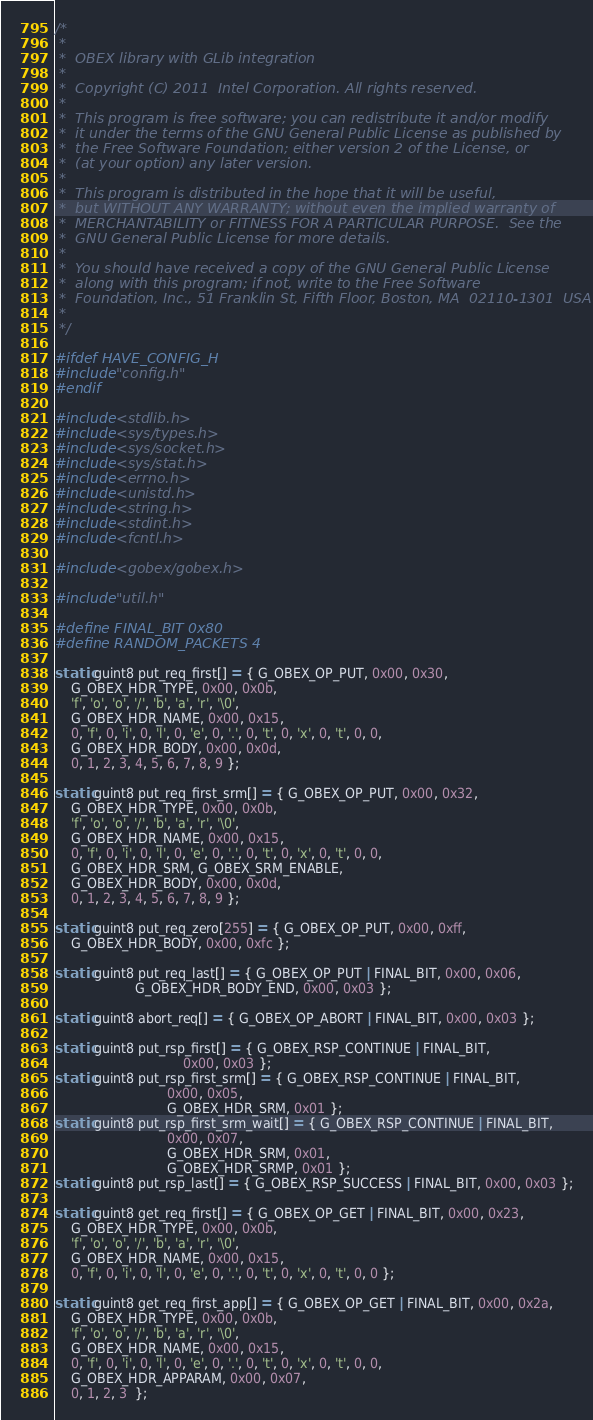Convert code to text. <code><loc_0><loc_0><loc_500><loc_500><_C_>/*
 *
 *  OBEX library with GLib integration
 *
 *  Copyright (C) 2011  Intel Corporation. All rights reserved.
 *
 *  This program is free software; you can redistribute it and/or modify
 *  it under the terms of the GNU General Public License as published by
 *  the Free Software Foundation; either version 2 of the License, or
 *  (at your option) any later version.
 *
 *  This program is distributed in the hope that it will be useful,
 *  but WITHOUT ANY WARRANTY; without even the implied warranty of
 *  MERCHANTABILITY or FITNESS FOR A PARTICULAR PURPOSE.  See the
 *  GNU General Public License for more details.
 *
 *  You should have received a copy of the GNU General Public License
 *  along with this program; if not, write to the Free Software
 *  Foundation, Inc., 51 Franklin St, Fifth Floor, Boston, MA  02110-1301  USA
 *
 */

#ifdef HAVE_CONFIG_H
#include "config.h"
#endif

#include <stdlib.h>
#include <sys/types.h>
#include <sys/socket.h>
#include <sys/stat.h>
#include <errno.h>
#include <unistd.h>
#include <string.h>
#include <stdint.h>
#include <fcntl.h>

#include <gobex/gobex.h>

#include "util.h"

#define FINAL_BIT 0x80
#define RANDOM_PACKETS 4

static guint8 put_req_first[] = { G_OBEX_OP_PUT, 0x00, 0x30,
	G_OBEX_HDR_TYPE, 0x00, 0x0b,
	'f', 'o', 'o', '/', 'b', 'a', 'r', '\0',
	G_OBEX_HDR_NAME, 0x00, 0x15,
	0, 'f', 0, 'i', 0, 'l', 0, 'e', 0, '.', 0, 't', 0, 'x', 0, 't', 0, 0,
	G_OBEX_HDR_BODY, 0x00, 0x0d,
	0, 1, 2, 3, 4, 5, 6, 7, 8, 9 };

static guint8 put_req_first_srm[] = { G_OBEX_OP_PUT, 0x00, 0x32,
	G_OBEX_HDR_TYPE, 0x00, 0x0b,
	'f', 'o', 'o', '/', 'b', 'a', 'r', '\0',
	G_OBEX_HDR_NAME, 0x00, 0x15,
	0, 'f', 0, 'i', 0, 'l', 0, 'e', 0, '.', 0, 't', 0, 'x', 0, 't', 0, 0,
	G_OBEX_HDR_SRM, G_OBEX_SRM_ENABLE,
	G_OBEX_HDR_BODY, 0x00, 0x0d,
	0, 1, 2, 3, 4, 5, 6, 7, 8, 9 };

static guint8 put_req_zero[255] = { G_OBEX_OP_PUT, 0x00, 0xff,
	G_OBEX_HDR_BODY, 0x00, 0xfc };

static guint8 put_req_last[] = { G_OBEX_OP_PUT | FINAL_BIT, 0x00, 0x06,
					G_OBEX_HDR_BODY_END, 0x00, 0x03 };

static guint8 abort_req[] = { G_OBEX_OP_ABORT | FINAL_BIT, 0x00, 0x03 };

static guint8 put_rsp_first[] = { G_OBEX_RSP_CONTINUE | FINAL_BIT,
								0x00, 0x03 };
static guint8 put_rsp_first_srm[] = { G_OBEX_RSP_CONTINUE | FINAL_BIT,
							0x00, 0x05,
							G_OBEX_HDR_SRM, 0x01 };
static guint8 put_rsp_first_srm_wait[] = { G_OBEX_RSP_CONTINUE | FINAL_BIT,
							0x00, 0x07,
							G_OBEX_HDR_SRM, 0x01,
							G_OBEX_HDR_SRMP, 0x01 };
static guint8 put_rsp_last[] = { G_OBEX_RSP_SUCCESS | FINAL_BIT, 0x00, 0x03 };

static guint8 get_req_first[] = { G_OBEX_OP_GET | FINAL_BIT, 0x00, 0x23,
	G_OBEX_HDR_TYPE, 0x00, 0x0b,
	'f', 'o', 'o', '/', 'b', 'a', 'r', '\0',
	G_OBEX_HDR_NAME, 0x00, 0x15,
	0, 'f', 0, 'i', 0, 'l', 0, 'e', 0, '.', 0, 't', 0, 'x', 0, 't', 0, 0 };

static guint8 get_req_first_app[] = { G_OBEX_OP_GET | FINAL_BIT, 0x00, 0x2a,
	G_OBEX_HDR_TYPE, 0x00, 0x0b,
	'f', 'o', 'o', '/', 'b', 'a', 'r', '\0',
	G_OBEX_HDR_NAME, 0x00, 0x15,
	0, 'f', 0, 'i', 0, 'l', 0, 'e', 0, '.', 0, 't', 0, 'x', 0, 't', 0, 0,
	G_OBEX_HDR_APPARAM, 0x00, 0x07,
	0, 1, 2, 3  };
</code> 